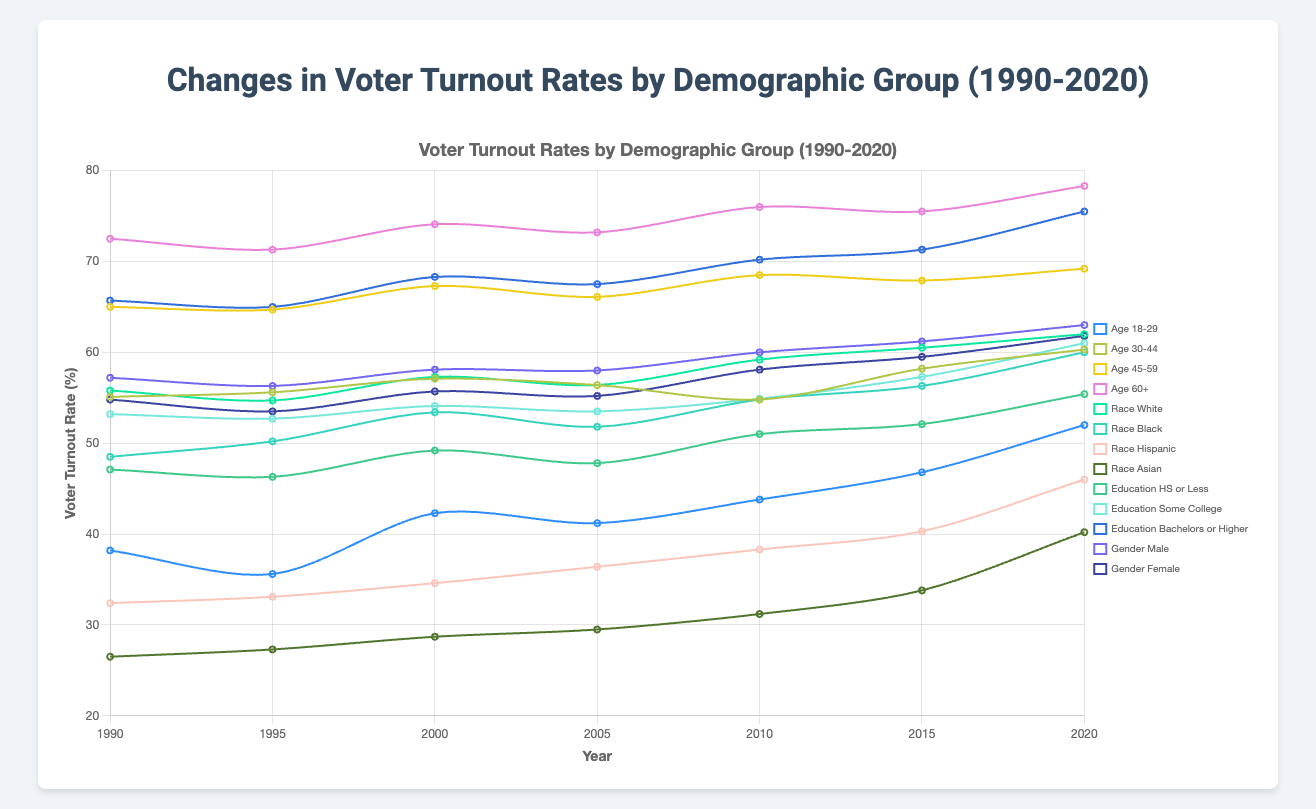Which age group had the highest voter turnout in 2020? The highest voter turnout rates in the 2020 national elections were recorded among the group aged 60 and above. To find this, look at the turnout rates for each age group and identify the highest value. The 60+ age group had the highest turnout rate of 78.3%.
Answer: Age 60+ What is the overall trend in voter turnout among the Hispanic demographic from 1990 to 2020? Observing the voter turnout rates of the Hispanic demographic from 1990 (32.4%) to 2020 (46.0%), there is a clear upward trend. Each election year shows an increase in the turnout rate when compared to the previous years.
Answer: Upward trend Compare the voter turnout rates of males and females in 2015. Which gender had a higher turnout? In 2015, the voter turnout rate for males was 61.2%, and for females, it was 59.5%. Comparing these numbers, males had a higher turnout rate in 2015.
Answer: Males Which demographic group showed the largest increase in voter turnout between 1990 and 2020? To determine which group had the largest increase in voter turnout, we calculate the difference between the 2020 and 1990 turnout rates for each demographic. The Asian demographic showed the largest increase, from 26.5% in 1990 to 40.2% in 2020, which is an increase of 13.7 percentage points.
Answer: Race Asian What is the average voter turnout rate for the 'Education Bachelor's or Higher' demographic over the three decades? To find the average turnout rate for this demographic from 1990 to 2020, sum the turnout rates (65.7 + 65.0 + 68.3 + 67.5 + 70.2 + 71.3 + 75.5) and divide by the number of rates (7). The sum is 483.5, and the average is 483.5 / 7 = 69.1.
Answer: 69.1 Which race had the lowest voter turnout in 1990, and what was the percentage? In 1990, the Asian demographic had the lowest voter turnout rate at 26.5%.
Answer: Race Asian, 26.5% Did the voter turnout rate for the Age 45-59 group increase or decrease from 2005 to 2010? The voter turnout rate for the Age 45-59 group in 2005 was 66.1%, while in 2010, it was 68.5%. Since 68.5% is higher than 66.1%, the turnout rate increased.
Answer: Increase By how much did the voter turnout rate for the Black demographic change from 1990 to 2020? The voter turnout rate for the Black demographic in 1990 was 48.5%, and in 2020 it was 60%. The change is calculated as 60.0% - 48.5% = 11.5 percentage points.
Answer: 11.5 percentage points How does the voter turnout rate of the 'Education High School or Less' demographic in 2020 compare to the 'Education Some College' demographic in 2000? The voter turnout rate for 'Education High School or Less' in 2020 was 55.4%, and for 'Education Some College' in 2000, it was 54.1%. Comparing these, 55.4% is greater than 54.1%.
Answer: Higher for Education High School or Less in 2020 